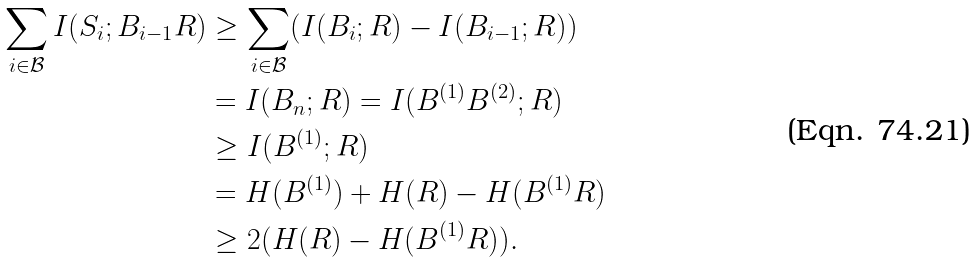Convert formula to latex. <formula><loc_0><loc_0><loc_500><loc_500>\sum _ { i \in \mathcal { B } } I ( S _ { i } ; B _ { i - 1 } R ) & \geq \sum _ { i \in \mathcal { B } } ( I ( B _ { i } ; R ) - I ( B _ { i - 1 } ; R ) ) \\ & = I ( B _ { n } ; R ) = I ( B ^ { ( 1 ) } B ^ { ( 2 ) } ; R ) \\ & \geq I ( B ^ { ( 1 ) } ; R ) \\ & = H ( B ^ { ( 1 ) } ) + H ( R ) - H ( B ^ { ( 1 ) } R ) \\ & \geq 2 ( H ( R ) - H ( B ^ { ( 1 ) } R ) ) .</formula> 